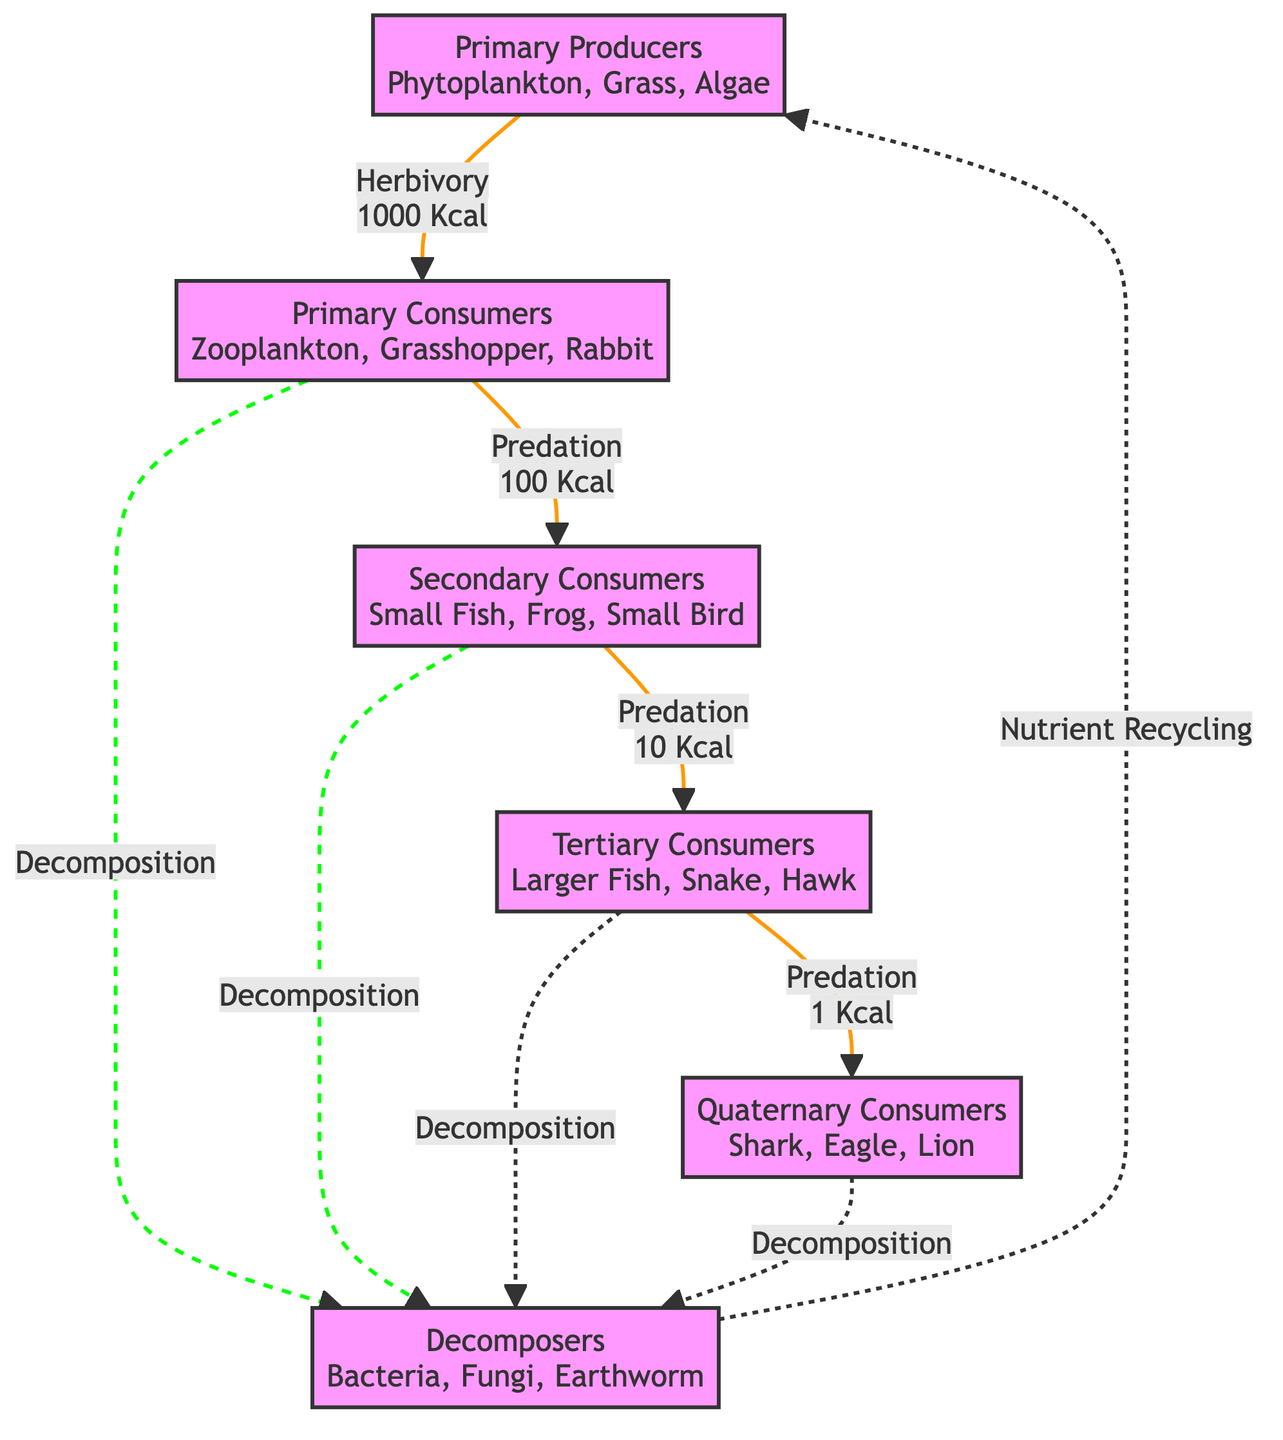What is the total energy flow from primary producers to primary consumers? The diagram indicates an energy flow of 1000 Kcal from primary producers to primary consumers, as shown by the energy link between the two nodes.
Answer: 1000 Kcal How many trophic levels are represented in the diagram? The diagram has five distinct trophic levels: primary producers, primary consumers, secondary consumers, tertiary consumers, and quaternary consumers, indicating a total of five levels.
Answer: 5 What is the energy flow from secondary consumers to tertiary consumers? The diagram explicitly indicates an energy flow of 10 Kcal from secondary consumers to tertiary consumers.
Answer: 10 Kcal Which group of organisms is classified as decomposers in the diagram? The diagram identifies bacteria, fungi, and earthworms as the decomposers, located at the bottom of the trophic structure.
Answer: Bacteria, Fungi, Earthworm What is the energy flow from tertiary consumers to quaternary consumers? The energy flow from tertiary consumers to quaternary consumers is 1 Kcal, supported by the arrow connecting those two trophic levels in the diagram.
Answer: 1 Kcal What process links all consumers to decomposers? The diagram shows that the process linking primary, secondary, tertiary, and quaternary consumers to decomposers is decomposition. This is indicated by the dashed lines leading from each consumer group to decomposers.
Answer: Decomposition What is recycled back to primary producers? According to the diagram, nutrients are recycled back to primary producers through the decomposition process. The arrow shows nutrient recycling directed towards primary producers from decomposers.
Answer: Nutrient Recycling How much energy is transferred from primary consumers to secondary consumers? The diagram indicates that 100 Kcal of energy is transferred from primary consumers to secondary consumers, which is explicitly stated on the arrow connecting these two nodes.
Answer: 100 Kcal What is the relationship between secondary consumers and tertiary consumers? The relationship is one of predation, with secondary consumers providing 10 Kcal of energy to tertiary consumers, as indicated by the label on their connecting link.
Answer: Predation 